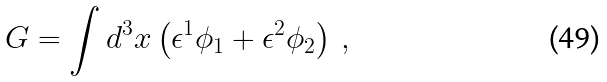<formula> <loc_0><loc_0><loc_500><loc_500>G = \int d ^ { 3 } x \left ( \epsilon ^ { 1 } \phi _ { 1 } + \epsilon ^ { 2 } \phi _ { 2 } \right ) \, ,</formula> 